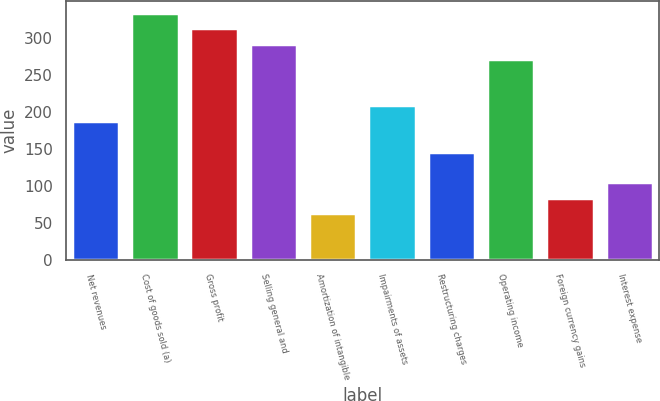Convert chart to OTSL. <chart><loc_0><loc_0><loc_500><loc_500><bar_chart><fcel>Net revenues<fcel>Cost of goods sold (a)<fcel>Gross profit<fcel>Selling general and<fcel>Amortization of intangible<fcel>Impairments of assets<fcel>Restructuring charges<fcel>Operating income<fcel>Foreign currency gains<fcel>Interest expense<nl><fcel>187.62<fcel>333.08<fcel>312.3<fcel>291.52<fcel>62.94<fcel>208.4<fcel>146.06<fcel>270.74<fcel>83.72<fcel>104.5<nl></chart> 